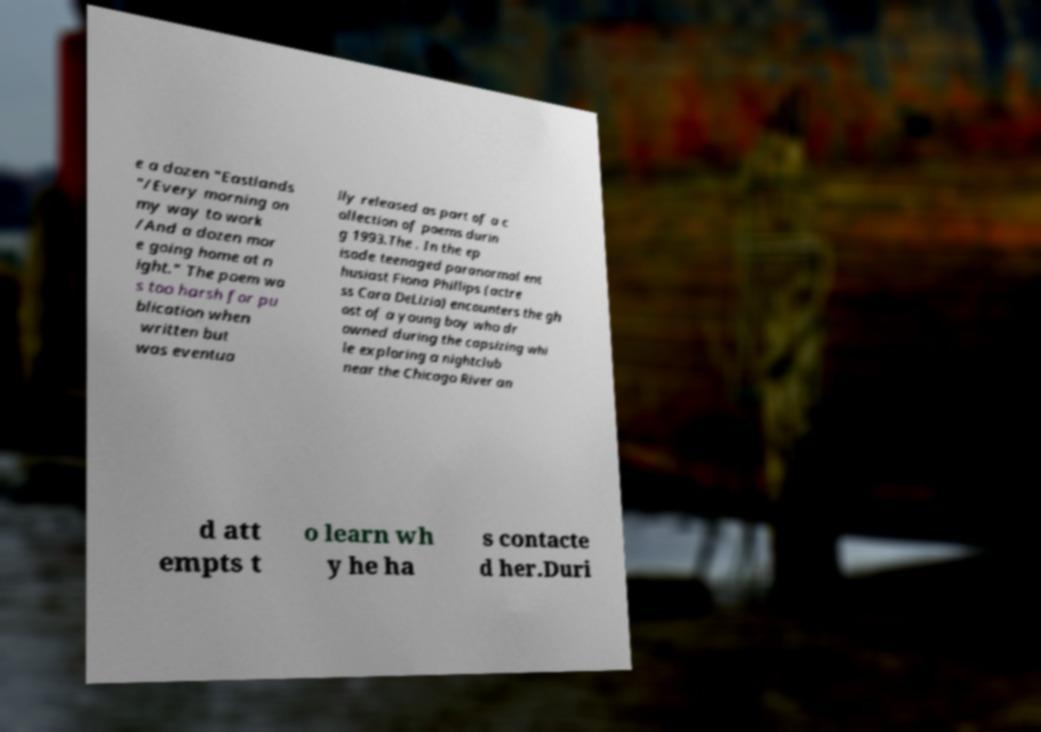For documentation purposes, I need the text within this image transcribed. Could you provide that? e a dozen "Eastlands "/Every morning on my way to work /And a dozen mor e going home at n ight." The poem wa s too harsh for pu blication when written but was eventua lly released as part of a c ollection of poems durin g 1993.The . In the ep isode teenaged paranormal ent husiast Fiona Phillips (actre ss Cara DeLizia) encounters the gh ost of a young boy who dr owned during the capsizing whi le exploring a nightclub near the Chicago River an d att empts t o learn wh y he ha s contacte d her.Duri 